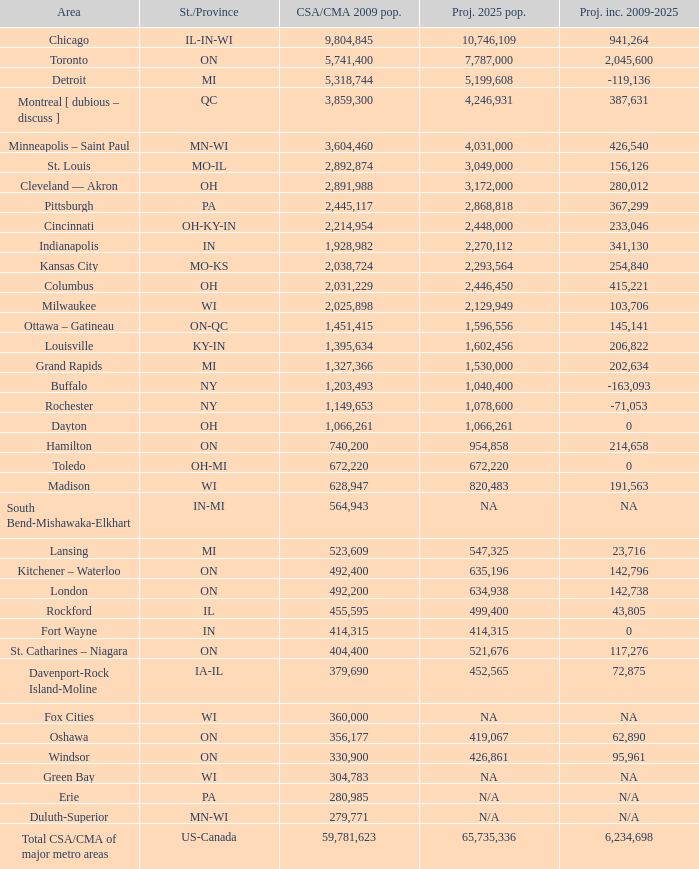What's the projected population of IN-MI? NA. 